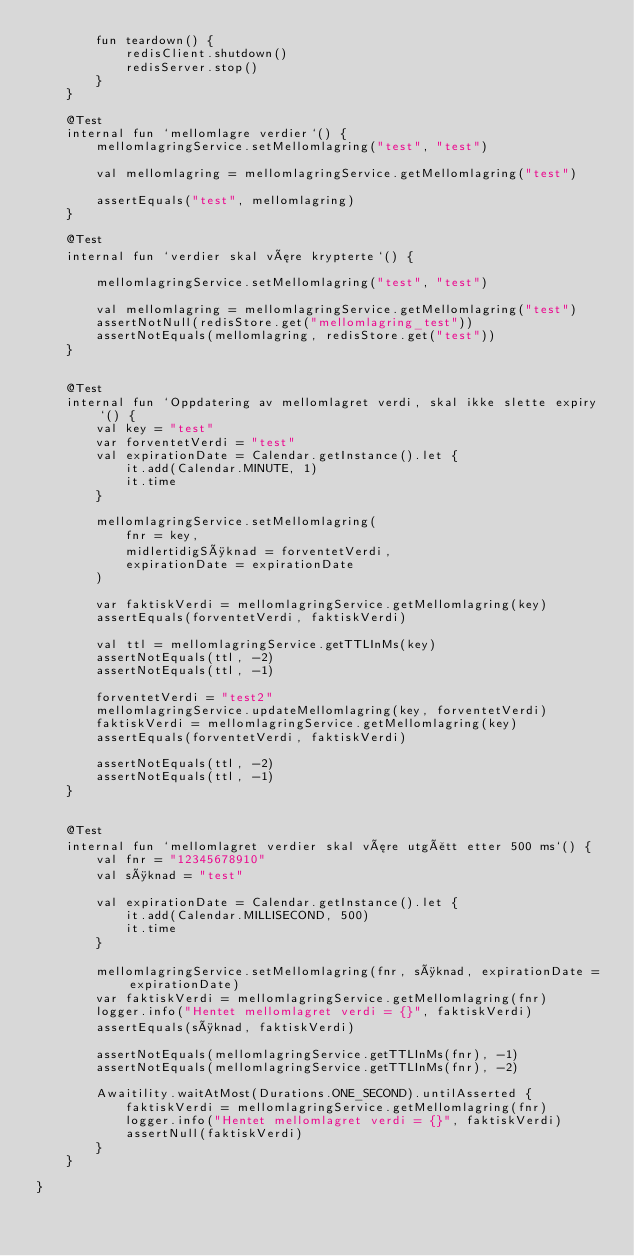Convert code to text. <code><loc_0><loc_0><loc_500><loc_500><_Kotlin_>        fun teardown() {
            redisClient.shutdown()
            redisServer.stop()
        }
    }

    @Test
    internal fun `mellomlagre verdier`() {
        mellomlagringService.setMellomlagring("test", "test")

        val mellomlagring = mellomlagringService.getMellomlagring("test")

        assertEquals("test", mellomlagring)
    }

    @Test
    internal fun `verdier skal være krypterte`() {

        mellomlagringService.setMellomlagring("test", "test")

        val mellomlagring = mellomlagringService.getMellomlagring("test")
        assertNotNull(redisStore.get("mellomlagring_test"))
        assertNotEquals(mellomlagring, redisStore.get("test"))
    }


    @Test
    internal fun `Oppdatering av mellomlagret verdi, skal ikke slette expiry`() {
        val key = "test"
        var forventetVerdi = "test"
        val expirationDate = Calendar.getInstance().let {
            it.add(Calendar.MINUTE, 1)
            it.time
        }

        mellomlagringService.setMellomlagring(
            fnr = key,
            midlertidigSøknad = forventetVerdi,
            expirationDate = expirationDate
        )

        var faktiskVerdi = mellomlagringService.getMellomlagring(key)
        assertEquals(forventetVerdi, faktiskVerdi)

        val ttl = mellomlagringService.getTTLInMs(key)
        assertNotEquals(ttl, -2)
        assertNotEquals(ttl, -1)

        forventetVerdi = "test2"
        mellomlagringService.updateMellomlagring(key, forventetVerdi)
        faktiskVerdi = mellomlagringService.getMellomlagring(key)
        assertEquals(forventetVerdi, faktiskVerdi)

        assertNotEquals(ttl, -2)
        assertNotEquals(ttl, -1)
    }


    @Test
    internal fun `mellomlagret verdier skal være utgått etter 500 ms`() {
        val fnr = "12345678910"
        val søknad = "test"

        val expirationDate = Calendar.getInstance().let {
            it.add(Calendar.MILLISECOND, 500)
            it.time
        }

        mellomlagringService.setMellomlagring(fnr, søknad, expirationDate = expirationDate)
        var faktiskVerdi = mellomlagringService.getMellomlagring(fnr)
        logger.info("Hentet mellomlagret verdi = {}", faktiskVerdi)
        assertEquals(søknad, faktiskVerdi)

        assertNotEquals(mellomlagringService.getTTLInMs(fnr), -1)
        assertNotEquals(mellomlagringService.getTTLInMs(fnr), -2)

        Awaitility.waitAtMost(Durations.ONE_SECOND).untilAsserted {
            faktiskVerdi = mellomlagringService.getMellomlagring(fnr)
            logger.info("Hentet mellomlagret verdi = {}", faktiskVerdi)
            assertNull(faktiskVerdi)
        }
    }

}</code> 